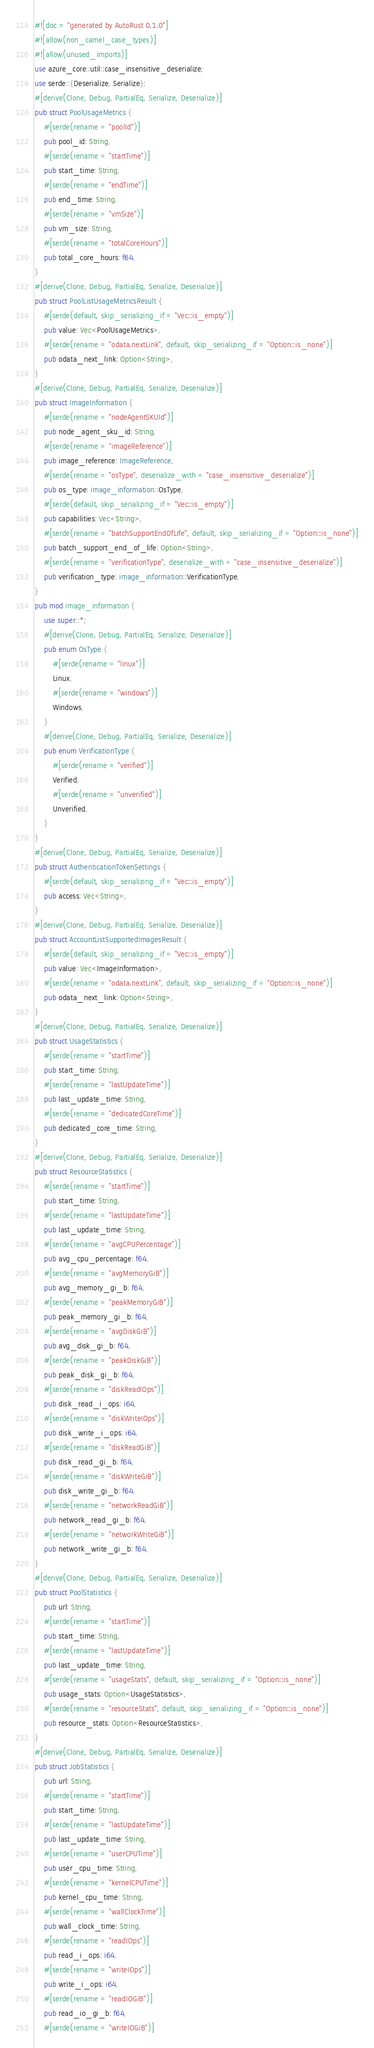Convert code to text. <code><loc_0><loc_0><loc_500><loc_500><_Rust_>#![doc = "generated by AutoRust 0.1.0"]
#![allow(non_camel_case_types)]
#![allow(unused_imports)]
use azure_core::util::case_insensitive_deserialize;
use serde::{Deserialize, Serialize};
#[derive(Clone, Debug, PartialEq, Serialize, Deserialize)]
pub struct PoolUsageMetrics {
    #[serde(rename = "poolId")]
    pub pool_id: String,
    #[serde(rename = "startTime")]
    pub start_time: String,
    #[serde(rename = "endTime")]
    pub end_time: String,
    #[serde(rename = "vmSize")]
    pub vm_size: String,
    #[serde(rename = "totalCoreHours")]
    pub total_core_hours: f64,
}
#[derive(Clone, Debug, PartialEq, Serialize, Deserialize)]
pub struct PoolListUsageMetricsResult {
    #[serde(default, skip_serializing_if = "Vec::is_empty")]
    pub value: Vec<PoolUsageMetrics>,
    #[serde(rename = "odata.nextLink", default, skip_serializing_if = "Option::is_none")]
    pub odata_next_link: Option<String>,
}
#[derive(Clone, Debug, PartialEq, Serialize, Deserialize)]
pub struct ImageInformation {
    #[serde(rename = "nodeAgentSKUId")]
    pub node_agent_sku_id: String,
    #[serde(rename = "imageReference")]
    pub image_reference: ImageReference,
    #[serde(rename = "osType", deserialize_with = "case_insensitive_deserialize")]
    pub os_type: image_information::OsType,
    #[serde(default, skip_serializing_if = "Vec::is_empty")]
    pub capabilities: Vec<String>,
    #[serde(rename = "batchSupportEndOfLife", default, skip_serializing_if = "Option::is_none")]
    pub batch_support_end_of_life: Option<String>,
    #[serde(rename = "verificationType", deserialize_with = "case_insensitive_deserialize")]
    pub verification_type: image_information::VerificationType,
}
pub mod image_information {
    use super::*;
    #[derive(Clone, Debug, PartialEq, Serialize, Deserialize)]
    pub enum OsType {
        #[serde(rename = "linux")]
        Linux,
        #[serde(rename = "windows")]
        Windows,
    }
    #[derive(Clone, Debug, PartialEq, Serialize, Deserialize)]
    pub enum VerificationType {
        #[serde(rename = "verified")]
        Verified,
        #[serde(rename = "unverified")]
        Unverified,
    }
}
#[derive(Clone, Debug, PartialEq, Serialize, Deserialize)]
pub struct AuthenticationTokenSettings {
    #[serde(default, skip_serializing_if = "Vec::is_empty")]
    pub access: Vec<String>,
}
#[derive(Clone, Debug, PartialEq, Serialize, Deserialize)]
pub struct AccountListSupportedImagesResult {
    #[serde(default, skip_serializing_if = "Vec::is_empty")]
    pub value: Vec<ImageInformation>,
    #[serde(rename = "odata.nextLink", default, skip_serializing_if = "Option::is_none")]
    pub odata_next_link: Option<String>,
}
#[derive(Clone, Debug, PartialEq, Serialize, Deserialize)]
pub struct UsageStatistics {
    #[serde(rename = "startTime")]
    pub start_time: String,
    #[serde(rename = "lastUpdateTime")]
    pub last_update_time: String,
    #[serde(rename = "dedicatedCoreTime")]
    pub dedicated_core_time: String,
}
#[derive(Clone, Debug, PartialEq, Serialize, Deserialize)]
pub struct ResourceStatistics {
    #[serde(rename = "startTime")]
    pub start_time: String,
    #[serde(rename = "lastUpdateTime")]
    pub last_update_time: String,
    #[serde(rename = "avgCPUPercentage")]
    pub avg_cpu_percentage: f64,
    #[serde(rename = "avgMemoryGiB")]
    pub avg_memory_gi_b: f64,
    #[serde(rename = "peakMemoryGiB")]
    pub peak_memory_gi_b: f64,
    #[serde(rename = "avgDiskGiB")]
    pub avg_disk_gi_b: f64,
    #[serde(rename = "peakDiskGiB")]
    pub peak_disk_gi_b: f64,
    #[serde(rename = "diskReadIOps")]
    pub disk_read_i_ops: i64,
    #[serde(rename = "diskWriteIOps")]
    pub disk_write_i_ops: i64,
    #[serde(rename = "diskReadGiB")]
    pub disk_read_gi_b: f64,
    #[serde(rename = "diskWriteGiB")]
    pub disk_write_gi_b: f64,
    #[serde(rename = "networkReadGiB")]
    pub network_read_gi_b: f64,
    #[serde(rename = "networkWriteGiB")]
    pub network_write_gi_b: f64,
}
#[derive(Clone, Debug, PartialEq, Serialize, Deserialize)]
pub struct PoolStatistics {
    pub url: String,
    #[serde(rename = "startTime")]
    pub start_time: String,
    #[serde(rename = "lastUpdateTime")]
    pub last_update_time: String,
    #[serde(rename = "usageStats", default, skip_serializing_if = "Option::is_none")]
    pub usage_stats: Option<UsageStatistics>,
    #[serde(rename = "resourceStats", default, skip_serializing_if = "Option::is_none")]
    pub resource_stats: Option<ResourceStatistics>,
}
#[derive(Clone, Debug, PartialEq, Serialize, Deserialize)]
pub struct JobStatistics {
    pub url: String,
    #[serde(rename = "startTime")]
    pub start_time: String,
    #[serde(rename = "lastUpdateTime")]
    pub last_update_time: String,
    #[serde(rename = "userCPUTime")]
    pub user_cpu_time: String,
    #[serde(rename = "kernelCPUTime")]
    pub kernel_cpu_time: String,
    #[serde(rename = "wallClockTime")]
    pub wall_clock_time: String,
    #[serde(rename = "readIOps")]
    pub read_i_ops: i64,
    #[serde(rename = "writeIOps")]
    pub write_i_ops: i64,
    #[serde(rename = "readIOGiB")]
    pub read_io_gi_b: f64,
    #[serde(rename = "writeIOGiB")]</code> 